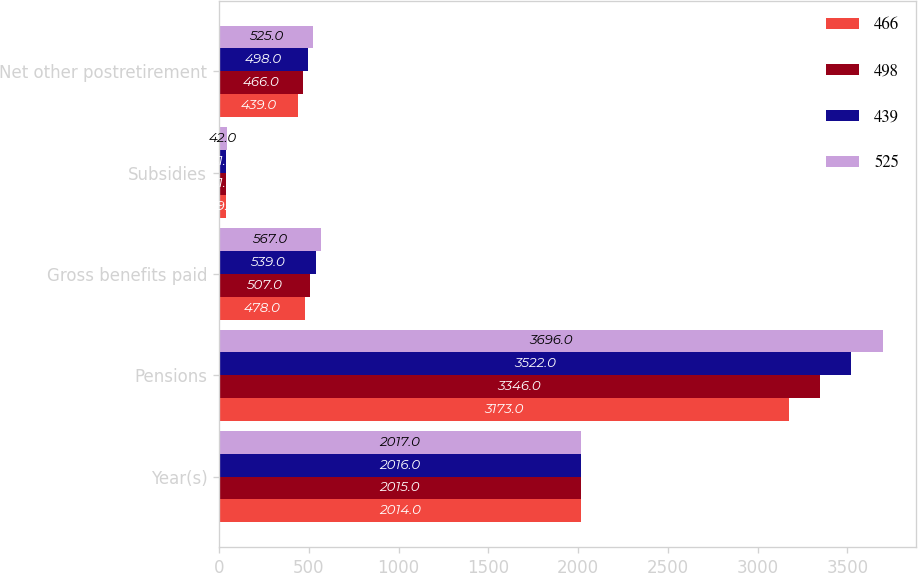<chart> <loc_0><loc_0><loc_500><loc_500><stacked_bar_chart><ecel><fcel>Year(s)<fcel>Pensions<fcel>Gross benefits paid<fcel>Subsidies<fcel>Net other postretirement<nl><fcel>466<fcel>2014<fcel>3173<fcel>478<fcel>39<fcel>439<nl><fcel>498<fcel>2015<fcel>3346<fcel>507<fcel>41<fcel>466<nl><fcel>439<fcel>2016<fcel>3522<fcel>539<fcel>41<fcel>498<nl><fcel>525<fcel>2017<fcel>3696<fcel>567<fcel>42<fcel>525<nl></chart> 